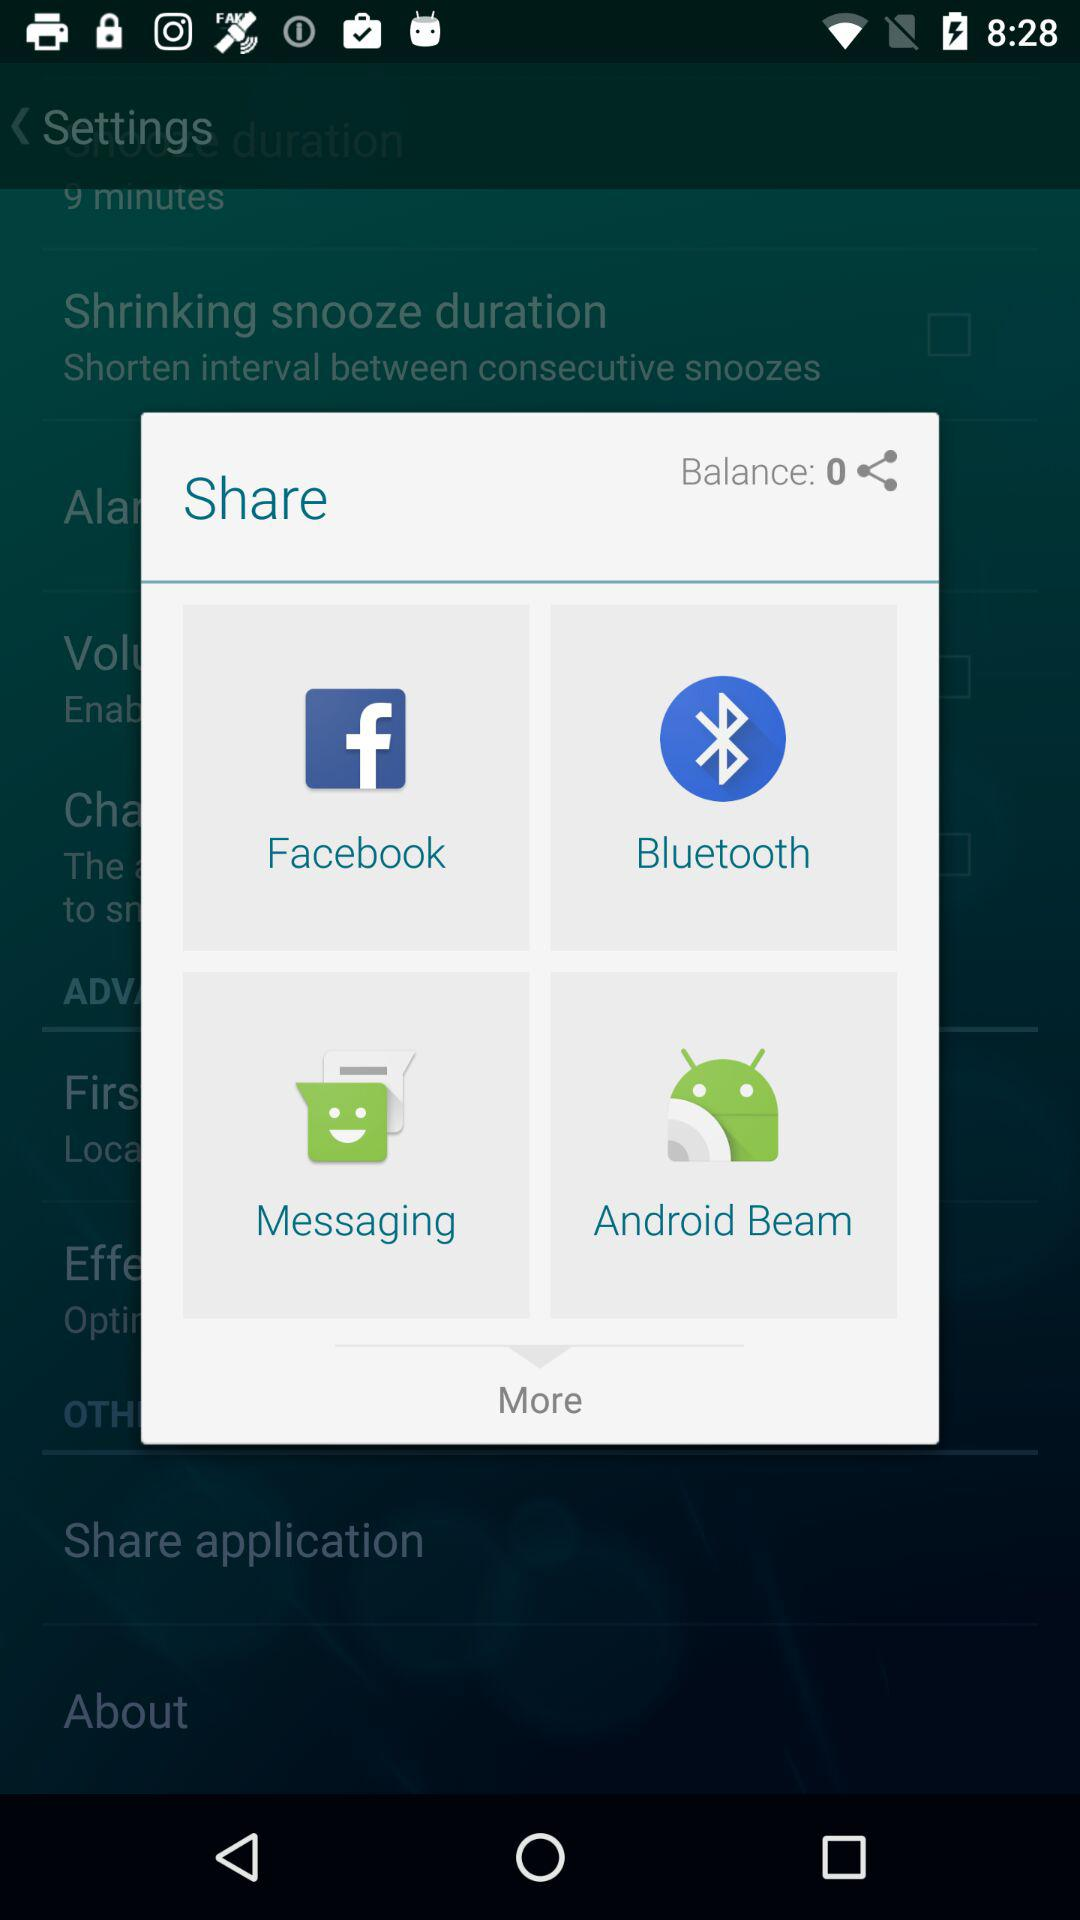What is the balance? The balance is 0. 